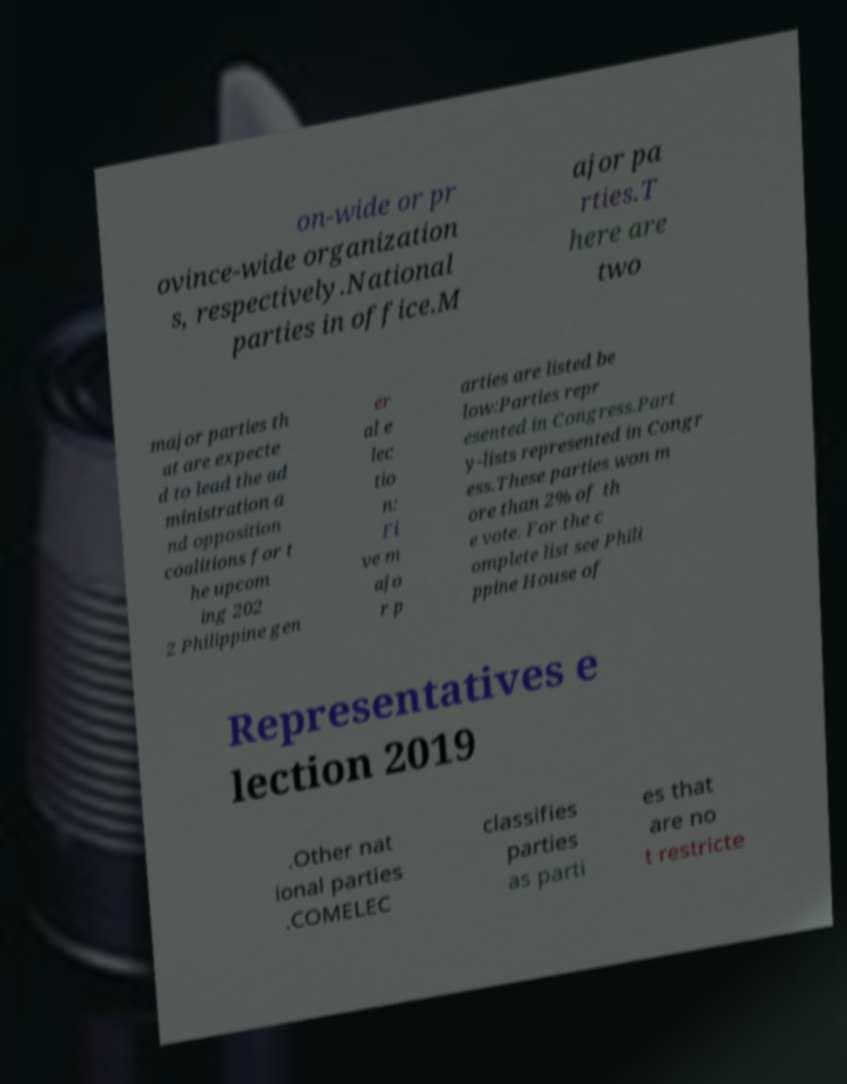For documentation purposes, I need the text within this image transcribed. Could you provide that? on-wide or pr ovince-wide organization s, respectively.National parties in office.M ajor pa rties.T here are two major parties th at are expecte d to lead the ad ministration a nd opposition coalitions for t he upcom ing 202 2 Philippine gen er al e lec tio n: Fi ve m ajo r p arties are listed be low:Parties repr esented in Congress.Part y-lists represented in Congr ess.These parties won m ore than 2% of th e vote. For the c omplete list see Phili ppine House of Representatives e lection 2019 .Other nat ional parties .COMELEC classifies parties as parti es that are no t restricte 